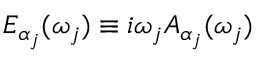<formula> <loc_0><loc_0><loc_500><loc_500>E _ { \alpha _ { j } } ( \omega _ { j } ) \equiv i \omega _ { j } A _ { \alpha _ { j } } ( \omega _ { j } )</formula> 